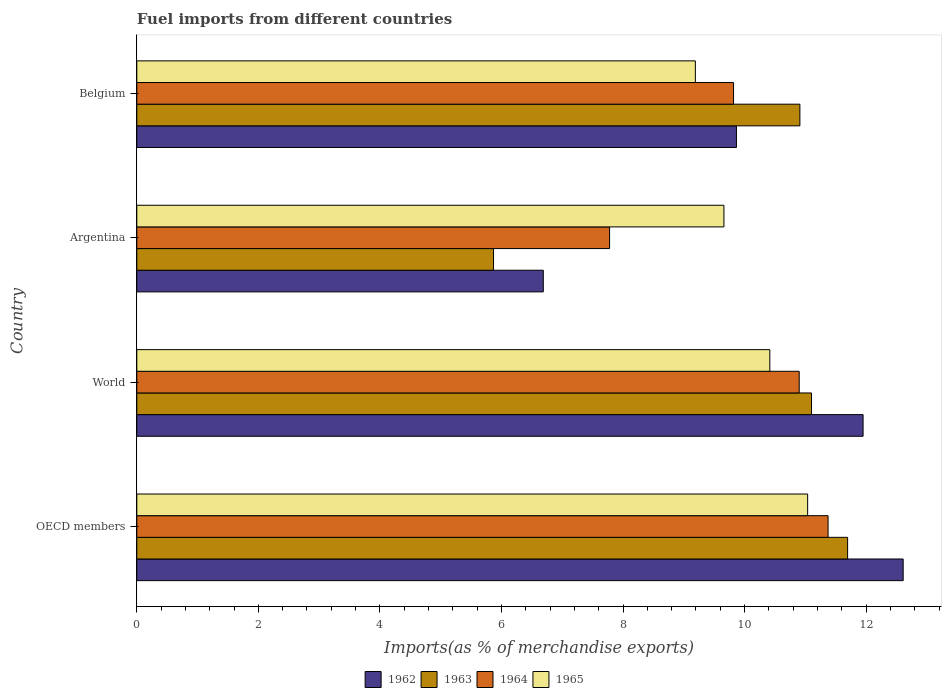How many groups of bars are there?
Make the answer very short. 4. Are the number of bars on each tick of the Y-axis equal?
Provide a short and direct response. Yes. How many bars are there on the 2nd tick from the top?
Your answer should be very brief. 4. How many bars are there on the 1st tick from the bottom?
Offer a terse response. 4. What is the label of the 1st group of bars from the top?
Make the answer very short. Belgium. In how many cases, is the number of bars for a given country not equal to the number of legend labels?
Give a very brief answer. 0. What is the percentage of imports to different countries in 1965 in World?
Ensure brevity in your answer.  10.42. Across all countries, what is the maximum percentage of imports to different countries in 1964?
Make the answer very short. 11.37. Across all countries, what is the minimum percentage of imports to different countries in 1962?
Your answer should be compact. 6.69. In which country was the percentage of imports to different countries in 1962 maximum?
Offer a very short reply. OECD members. What is the total percentage of imports to different countries in 1965 in the graph?
Offer a terse response. 40.31. What is the difference between the percentage of imports to different countries in 1962 in Belgium and that in OECD members?
Your response must be concise. -2.74. What is the difference between the percentage of imports to different countries in 1965 in Argentina and the percentage of imports to different countries in 1964 in World?
Offer a terse response. -1.24. What is the average percentage of imports to different countries in 1963 per country?
Offer a very short reply. 9.89. What is the difference between the percentage of imports to different countries in 1964 and percentage of imports to different countries in 1963 in Belgium?
Your answer should be very brief. -1.09. What is the ratio of the percentage of imports to different countries in 1962 in Argentina to that in OECD members?
Your answer should be very brief. 0.53. What is the difference between the highest and the second highest percentage of imports to different countries in 1965?
Give a very brief answer. 0.62. What is the difference between the highest and the lowest percentage of imports to different countries in 1965?
Ensure brevity in your answer.  1.85. In how many countries, is the percentage of imports to different countries in 1963 greater than the average percentage of imports to different countries in 1963 taken over all countries?
Your answer should be compact. 3. How many bars are there?
Provide a succinct answer. 16. Are all the bars in the graph horizontal?
Provide a short and direct response. Yes. Are the values on the major ticks of X-axis written in scientific E-notation?
Give a very brief answer. No. Does the graph contain grids?
Offer a terse response. No. How are the legend labels stacked?
Your answer should be very brief. Horizontal. What is the title of the graph?
Your response must be concise. Fuel imports from different countries. What is the label or title of the X-axis?
Provide a succinct answer. Imports(as % of merchandise exports). What is the Imports(as % of merchandise exports) in 1962 in OECD members?
Provide a short and direct response. 12.61. What is the Imports(as % of merchandise exports) in 1963 in OECD members?
Ensure brevity in your answer.  11.7. What is the Imports(as % of merchandise exports) in 1964 in OECD members?
Your answer should be compact. 11.37. What is the Imports(as % of merchandise exports) of 1965 in OECD members?
Ensure brevity in your answer.  11.04. What is the Imports(as % of merchandise exports) of 1962 in World?
Make the answer very short. 11.95. What is the Imports(as % of merchandise exports) in 1963 in World?
Keep it short and to the point. 11.1. What is the Imports(as % of merchandise exports) in 1964 in World?
Your response must be concise. 10.9. What is the Imports(as % of merchandise exports) of 1965 in World?
Offer a terse response. 10.42. What is the Imports(as % of merchandise exports) of 1962 in Argentina?
Offer a very short reply. 6.69. What is the Imports(as % of merchandise exports) in 1963 in Argentina?
Keep it short and to the point. 5.87. What is the Imports(as % of merchandise exports) of 1964 in Argentina?
Make the answer very short. 7.78. What is the Imports(as % of merchandise exports) of 1965 in Argentina?
Your answer should be very brief. 9.66. What is the Imports(as % of merchandise exports) in 1962 in Belgium?
Ensure brevity in your answer.  9.87. What is the Imports(as % of merchandise exports) in 1963 in Belgium?
Make the answer very short. 10.91. What is the Imports(as % of merchandise exports) in 1964 in Belgium?
Provide a short and direct response. 9.82. What is the Imports(as % of merchandise exports) in 1965 in Belgium?
Offer a terse response. 9.19. Across all countries, what is the maximum Imports(as % of merchandise exports) in 1962?
Offer a terse response. 12.61. Across all countries, what is the maximum Imports(as % of merchandise exports) of 1963?
Provide a succinct answer. 11.7. Across all countries, what is the maximum Imports(as % of merchandise exports) in 1964?
Give a very brief answer. 11.37. Across all countries, what is the maximum Imports(as % of merchandise exports) of 1965?
Give a very brief answer. 11.04. Across all countries, what is the minimum Imports(as % of merchandise exports) of 1962?
Provide a short and direct response. 6.69. Across all countries, what is the minimum Imports(as % of merchandise exports) of 1963?
Make the answer very short. 5.87. Across all countries, what is the minimum Imports(as % of merchandise exports) of 1964?
Make the answer very short. 7.78. Across all countries, what is the minimum Imports(as % of merchandise exports) in 1965?
Give a very brief answer. 9.19. What is the total Imports(as % of merchandise exports) of 1962 in the graph?
Give a very brief answer. 41.12. What is the total Imports(as % of merchandise exports) in 1963 in the graph?
Give a very brief answer. 39.58. What is the total Imports(as % of merchandise exports) in 1964 in the graph?
Your answer should be compact. 39.87. What is the total Imports(as % of merchandise exports) of 1965 in the graph?
Give a very brief answer. 40.31. What is the difference between the Imports(as % of merchandise exports) in 1962 in OECD members and that in World?
Give a very brief answer. 0.66. What is the difference between the Imports(as % of merchandise exports) of 1963 in OECD members and that in World?
Ensure brevity in your answer.  0.59. What is the difference between the Imports(as % of merchandise exports) in 1964 in OECD members and that in World?
Your answer should be compact. 0.48. What is the difference between the Imports(as % of merchandise exports) of 1965 in OECD members and that in World?
Offer a terse response. 0.62. What is the difference between the Imports(as % of merchandise exports) of 1962 in OECD members and that in Argentina?
Make the answer very short. 5.92. What is the difference between the Imports(as % of merchandise exports) in 1963 in OECD members and that in Argentina?
Give a very brief answer. 5.83. What is the difference between the Imports(as % of merchandise exports) in 1964 in OECD members and that in Argentina?
Make the answer very short. 3.59. What is the difference between the Imports(as % of merchandise exports) in 1965 in OECD members and that in Argentina?
Provide a short and direct response. 1.38. What is the difference between the Imports(as % of merchandise exports) of 1962 in OECD members and that in Belgium?
Give a very brief answer. 2.74. What is the difference between the Imports(as % of merchandise exports) of 1963 in OECD members and that in Belgium?
Ensure brevity in your answer.  0.79. What is the difference between the Imports(as % of merchandise exports) of 1964 in OECD members and that in Belgium?
Offer a very short reply. 1.56. What is the difference between the Imports(as % of merchandise exports) of 1965 in OECD members and that in Belgium?
Make the answer very short. 1.85. What is the difference between the Imports(as % of merchandise exports) of 1962 in World and that in Argentina?
Provide a succinct answer. 5.26. What is the difference between the Imports(as % of merchandise exports) in 1963 in World and that in Argentina?
Make the answer very short. 5.23. What is the difference between the Imports(as % of merchandise exports) of 1964 in World and that in Argentina?
Ensure brevity in your answer.  3.12. What is the difference between the Imports(as % of merchandise exports) in 1965 in World and that in Argentina?
Provide a short and direct response. 0.76. What is the difference between the Imports(as % of merchandise exports) in 1962 in World and that in Belgium?
Your response must be concise. 2.08. What is the difference between the Imports(as % of merchandise exports) of 1963 in World and that in Belgium?
Keep it short and to the point. 0.19. What is the difference between the Imports(as % of merchandise exports) in 1964 in World and that in Belgium?
Keep it short and to the point. 1.08. What is the difference between the Imports(as % of merchandise exports) of 1965 in World and that in Belgium?
Ensure brevity in your answer.  1.23. What is the difference between the Imports(as % of merchandise exports) in 1962 in Argentina and that in Belgium?
Your answer should be very brief. -3.18. What is the difference between the Imports(as % of merchandise exports) of 1963 in Argentina and that in Belgium?
Make the answer very short. -5.04. What is the difference between the Imports(as % of merchandise exports) in 1964 in Argentina and that in Belgium?
Give a very brief answer. -2.04. What is the difference between the Imports(as % of merchandise exports) of 1965 in Argentina and that in Belgium?
Offer a terse response. 0.47. What is the difference between the Imports(as % of merchandise exports) in 1962 in OECD members and the Imports(as % of merchandise exports) in 1963 in World?
Ensure brevity in your answer.  1.51. What is the difference between the Imports(as % of merchandise exports) in 1962 in OECD members and the Imports(as % of merchandise exports) in 1964 in World?
Provide a short and direct response. 1.71. What is the difference between the Imports(as % of merchandise exports) of 1962 in OECD members and the Imports(as % of merchandise exports) of 1965 in World?
Provide a short and direct response. 2.19. What is the difference between the Imports(as % of merchandise exports) of 1963 in OECD members and the Imports(as % of merchandise exports) of 1964 in World?
Give a very brief answer. 0.8. What is the difference between the Imports(as % of merchandise exports) in 1963 in OECD members and the Imports(as % of merchandise exports) in 1965 in World?
Make the answer very short. 1.28. What is the difference between the Imports(as % of merchandise exports) in 1964 in OECD members and the Imports(as % of merchandise exports) in 1965 in World?
Provide a short and direct response. 0.96. What is the difference between the Imports(as % of merchandise exports) of 1962 in OECD members and the Imports(as % of merchandise exports) of 1963 in Argentina?
Provide a succinct answer. 6.74. What is the difference between the Imports(as % of merchandise exports) in 1962 in OECD members and the Imports(as % of merchandise exports) in 1964 in Argentina?
Keep it short and to the point. 4.83. What is the difference between the Imports(as % of merchandise exports) of 1962 in OECD members and the Imports(as % of merchandise exports) of 1965 in Argentina?
Your answer should be very brief. 2.95. What is the difference between the Imports(as % of merchandise exports) of 1963 in OECD members and the Imports(as % of merchandise exports) of 1964 in Argentina?
Your answer should be very brief. 3.92. What is the difference between the Imports(as % of merchandise exports) of 1963 in OECD members and the Imports(as % of merchandise exports) of 1965 in Argentina?
Provide a short and direct response. 2.04. What is the difference between the Imports(as % of merchandise exports) of 1964 in OECD members and the Imports(as % of merchandise exports) of 1965 in Argentina?
Your answer should be compact. 1.71. What is the difference between the Imports(as % of merchandise exports) of 1962 in OECD members and the Imports(as % of merchandise exports) of 1963 in Belgium?
Ensure brevity in your answer.  1.7. What is the difference between the Imports(as % of merchandise exports) of 1962 in OECD members and the Imports(as % of merchandise exports) of 1964 in Belgium?
Your response must be concise. 2.79. What is the difference between the Imports(as % of merchandise exports) in 1962 in OECD members and the Imports(as % of merchandise exports) in 1965 in Belgium?
Your response must be concise. 3.42. What is the difference between the Imports(as % of merchandise exports) in 1963 in OECD members and the Imports(as % of merchandise exports) in 1964 in Belgium?
Provide a short and direct response. 1.88. What is the difference between the Imports(as % of merchandise exports) in 1963 in OECD members and the Imports(as % of merchandise exports) in 1965 in Belgium?
Keep it short and to the point. 2.51. What is the difference between the Imports(as % of merchandise exports) in 1964 in OECD members and the Imports(as % of merchandise exports) in 1965 in Belgium?
Provide a short and direct response. 2.18. What is the difference between the Imports(as % of merchandise exports) in 1962 in World and the Imports(as % of merchandise exports) in 1963 in Argentina?
Offer a very short reply. 6.08. What is the difference between the Imports(as % of merchandise exports) in 1962 in World and the Imports(as % of merchandise exports) in 1964 in Argentina?
Offer a very short reply. 4.17. What is the difference between the Imports(as % of merchandise exports) in 1962 in World and the Imports(as % of merchandise exports) in 1965 in Argentina?
Your answer should be compact. 2.29. What is the difference between the Imports(as % of merchandise exports) of 1963 in World and the Imports(as % of merchandise exports) of 1964 in Argentina?
Offer a terse response. 3.32. What is the difference between the Imports(as % of merchandise exports) in 1963 in World and the Imports(as % of merchandise exports) in 1965 in Argentina?
Make the answer very short. 1.44. What is the difference between the Imports(as % of merchandise exports) of 1964 in World and the Imports(as % of merchandise exports) of 1965 in Argentina?
Offer a terse response. 1.24. What is the difference between the Imports(as % of merchandise exports) in 1962 in World and the Imports(as % of merchandise exports) in 1963 in Belgium?
Offer a very short reply. 1.04. What is the difference between the Imports(as % of merchandise exports) in 1962 in World and the Imports(as % of merchandise exports) in 1964 in Belgium?
Offer a very short reply. 2.13. What is the difference between the Imports(as % of merchandise exports) of 1962 in World and the Imports(as % of merchandise exports) of 1965 in Belgium?
Provide a short and direct response. 2.76. What is the difference between the Imports(as % of merchandise exports) in 1963 in World and the Imports(as % of merchandise exports) in 1964 in Belgium?
Ensure brevity in your answer.  1.28. What is the difference between the Imports(as % of merchandise exports) of 1963 in World and the Imports(as % of merchandise exports) of 1965 in Belgium?
Your response must be concise. 1.91. What is the difference between the Imports(as % of merchandise exports) in 1964 in World and the Imports(as % of merchandise exports) in 1965 in Belgium?
Offer a very short reply. 1.71. What is the difference between the Imports(as % of merchandise exports) of 1962 in Argentina and the Imports(as % of merchandise exports) of 1963 in Belgium?
Offer a terse response. -4.22. What is the difference between the Imports(as % of merchandise exports) in 1962 in Argentina and the Imports(as % of merchandise exports) in 1964 in Belgium?
Ensure brevity in your answer.  -3.13. What is the difference between the Imports(as % of merchandise exports) in 1962 in Argentina and the Imports(as % of merchandise exports) in 1965 in Belgium?
Your answer should be compact. -2.5. What is the difference between the Imports(as % of merchandise exports) of 1963 in Argentina and the Imports(as % of merchandise exports) of 1964 in Belgium?
Your answer should be very brief. -3.95. What is the difference between the Imports(as % of merchandise exports) in 1963 in Argentina and the Imports(as % of merchandise exports) in 1965 in Belgium?
Keep it short and to the point. -3.32. What is the difference between the Imports(as % of merchandise exports) in 1964 in Argentina and the Imports(as % of merchandise exports) in 1965 in Belgium?
Your response must be concise. -1.41. What is the average Imports(as % of merchandise exports) in 1962 per country?
Make the answer very short. 10.28. What is the average Imports(as % of merchandise exports) of 1963 per country?
Offer a very short reply. 9.89. What is the average Imports(as % of merchandise exports) in 1964 per country?
Provide a short and direct response. 9.97. What is the average Imports(as % of merchandise exports) of 1965 per country?
Offer a terse response. 10.08. What is the difference between the Imports(as % of merchandise exports) of 1962 and Imports(as % of merchandise exports) of 1963 in OECD members?
Your answer should be very brief. 0.91. What is the difference between the Imports(as % of merchandise exports) in 1962 and Imports(as % of merchandise exports) in 1964 in OECD members?
Your response must be concise. 1.24. What is the difference between the Imports(as % of merchandise exports) of 1962 and Imports(as % of merchandise exports) of 1965 in OECD members?
Make the answer very short. 1.57. What is the difference between the Imports(as % of merchandise exports) in 1963 and Imports(as % of merchandise exports) in 1964 in OECD members?
Give a very brief answer. 0.32. What is the difference between the Imports(as % of merchandise exports) of 1963 and Imports(as % of merchandise exports) of 1965 in OECD members?
Provide a short and direct response. 0.66. What is the difference between the Imports(as % of merchandise exports) of 1964 and Imports(as % of merchandise exports) of 1965 in OECD members?
Offer a terse response. 0.34. What is the difference between the Imports(as % of merchandise exports) of 1962 and Imports(as % of merchandise exports) of 1963 in World?
Provide a succinct answer. 0.85. What is the difference between the Imports(as % of merchandise exports) of 1962 and Imports(as % of merchandise exports) of 1964 in World?
Give a very brief answer. 1.05. What is the difference between the Imports(as % of merchandise exports) in 1962 and Imports(as % of merchandise exports) in 1965 in World?
Ensure brevity in your answer.  1.53. What is the difference between the Imports(as % of merchandise exports) of 1963 and Imports(as % of merchandise exports) of 1964 in World?
Provide a succinct answer. 0.2. What is the difference between the Imports(as % of merchandise exports) in 1963 and Imports(as % of merchandise exports) in 1965 in World?
Make the answer very short. 0.69. What is the difference between the Imports(as % of merchandise exports) of 1964 and Imports(as % of merchandise exports) of 1965 in World?
Your answer should be very brief. 0.48. What is the difference between the Imports(as % of merchandise exports) of 1962 and Imports(as % of merchandise exports) of 1963 in Argentina?
Offer a terse response. 0.82. What is the difference between the Imports(as % of merchandise exports) in 1962 and Imports(as % of merchandise exports) in 1964 in Argentina?
Offer a terse response. -1.09. What is the difference between the Imports(as % of merchandise exports) in 1962 and Imports(as % of merchandise exports) in 1965 in Argentina?
Provide a succinct answer. -2.97. What is the difference between the Imports(as % of merchandise exports) of 1963 and Imports(as % of merchandise exports) of 1964 in Argentina?
Provide a short and direct response. -1.91. What is the difference between the Imports(as % of merchandise exports) of 1963 and Imports(as % of merchandise exports) of 1965 in Argentina?
Your answer should be compact. -3.79. What is the difference between the Imports(as % of merchandise exports) in 1964 and Imports(as % of merchandise exports) in 1965 in Argentina?
Keep it short and to the point. -1.88. What is the difference between the Imports(as % of merchandise exports) of 1962 and Imports(as % of merchandise exports) of 1963 in Belgium?
Ensure brevity in your answer.  -1.04. What is the difference between the Imports(as % of merchandise exports) of 1962 and Imports(as % of merchandise exports) of 1964 in Belgium?
Offer a terse response. 0.05. What is the difference between the Imports(as % of merchandise exports) of 1962 and Imports(as % of merchandise exports) of 1965 in Belgium?
Provide a succinct answer. 0.68. What is the difference between the Imports(as % of merchandise exports) of 1963 and Imports(as % of merchandise exports) of 1964 in Belgium?
Your answer should be very brief. 1.09. What is the difference between the Imports(as % of merchandise exports) in 1963 and Imports(as % of merchandise exports) in 1965 in Belgium?
Provide a succinct answer. 1.72. What is the difference between the Imports(as % of merchandise exports) of 1964 and Imports(as % of merchandise exports) of 1965 in Belgium?
Make the answer very short. 0.63. What is the ratio of the Imports(as % of merchandise exports) in 1962 in OECD members to that in World?
Provide a succinct answer. 1.06. What is the ratio of the Imports(as % of merchandise exports) of 1963 in OECD members to that in World?
Give a very brief answer. 1.05. What is the ratio of the Imports(as % of merchandise exports) in 1964 in OECD members to that in World?
Offer a very short reply. 1.04. What is the ratio of the Imports(as % of merchandise exports) of 1965 in OECD members to that in World?
Give a very brief answer. 1.06. What is the ratio of the Imports(as % of merchandise exports) in 1962 in OECD members to that in Argentina?
Keep it short and to the point. 1.89. What is the ratio of the Imports(as % of merchandise exports) of 1963 in OECD members to that in Argentina?
Provide a short and direct response. 1.99. What is the ratio of the Imports(as % of merchandise exports) of 1964 in OECD members to that in Argentina?
Give a very brief answer. 1.46. What is the ratio of the Imports(as % of merchandise exports) of 1965 in OECD members to that in Argentina?
Offer a terse response. 1.14. What is the ratio of the Imports(as % of merchandise exports) in 1962 in OECD members to that in Belgium?
Provide a short and direct response. 1.28. What is the ratio of the Imports(as % of merchandise exports) of 1963 in OECD members to that in Belgium?
Offer a terse response. 1.07. What is the ratio of the Imports(as % of merchandise exports) in 1964 in OECD members to that in Belgium?
Make the answer very short. 1.16. What is the ratio of the Imports(as % of merchandise exports) of 1965 in OECD members to that in Belgium?
Your answer should be very brief. 1.2. What is the ratio of the Imports(as % of merchandise exports) of 1962 in World to that in Argentina?
Your answer should be very brief. 1.79. What is the ratio of the Imports(as % of merchandise exports) of 1963 in World to that in Argentina?
Keep it short and to the point. 1.89. What is the ratio of the Imports(as % of merchandise exports) in 1964 in World to that in Argentina?
Your response must be concise. 1.4. What is the ratio of the Imports(as % of merchandise exports) of 1965 in World to that in Argentina?
Keep it short and to the point. 1.08. What is the ratio of the Imports(as % of merchandise exports) of 1962 in World to that in Belgium?
Your answer should be compact. 1.21. What is the ratio of the Imports(as % of merchandise exports) of 1963 in World to that in Belgium?
Your response must be concise. 1.02. What is the ratio of the Imports(as % of merchandise exports) in 1964 in World to that in Belgium?
Your answer should be compact. 1.11. What is the ratio of the Imports(as % of merchandise exports) in 1965 in World to that in Belgium?
Your answer should be compact. 1.13. What is the ratio of the Imports(as % of merchandise exports) of 1962 in Argentina to that in Belgium?
Your answer should be compact. 0.68. What is the ratio of the Imports(as % of merchandise exports) of 1963 in Argentina to that in Belgium?
Give a very brief answer. 0.54. What is the ratio of the Imports(as % of merchandise exports) in 1964 in Argentina to that in Belgium?
Provide a succinct answer. 0.79. What is the ratio of the Imports(as % of merchandise exports) of 1965 in Argentina to that in Belgium?
Ensure brevity in your answer.  1.05. What is the difference between the highest and the second highest Imports(as % of merchandise exports) of 1962?
Your answer should be very brief. 0.66. What is the difference between the highest and the second highest Imports(as % of merchandise exports) in 1963?
Make the answer very short. 0.59. What is the difference between the highest and the second highest Imports(as % of merchandise exports) in 1964?
Give a very brief answer. 0.48. What is the difference between the highest and the second highest Imports(as % of merchandise exports) of 1965?
Provide a succinct answer. 0.62. What is the difference between the highest and the lowest Imports(as % of merchandise exports) in 1962?
Provide a succinct answer. 5.92. What is the difference between the highest and the lowest Imports(as % of merchandise exports) of 1963?
Offer a terse response. 5.83. What is the difference between the highest and the lowest Imports(as % of merchandise exports) in 1964?
Provide a short and direct response. 3.59. What is the difference between the highest and the lowest Imports(as % of merchandise exports) in 1965?
Keep it short and to the point. 1.85. 